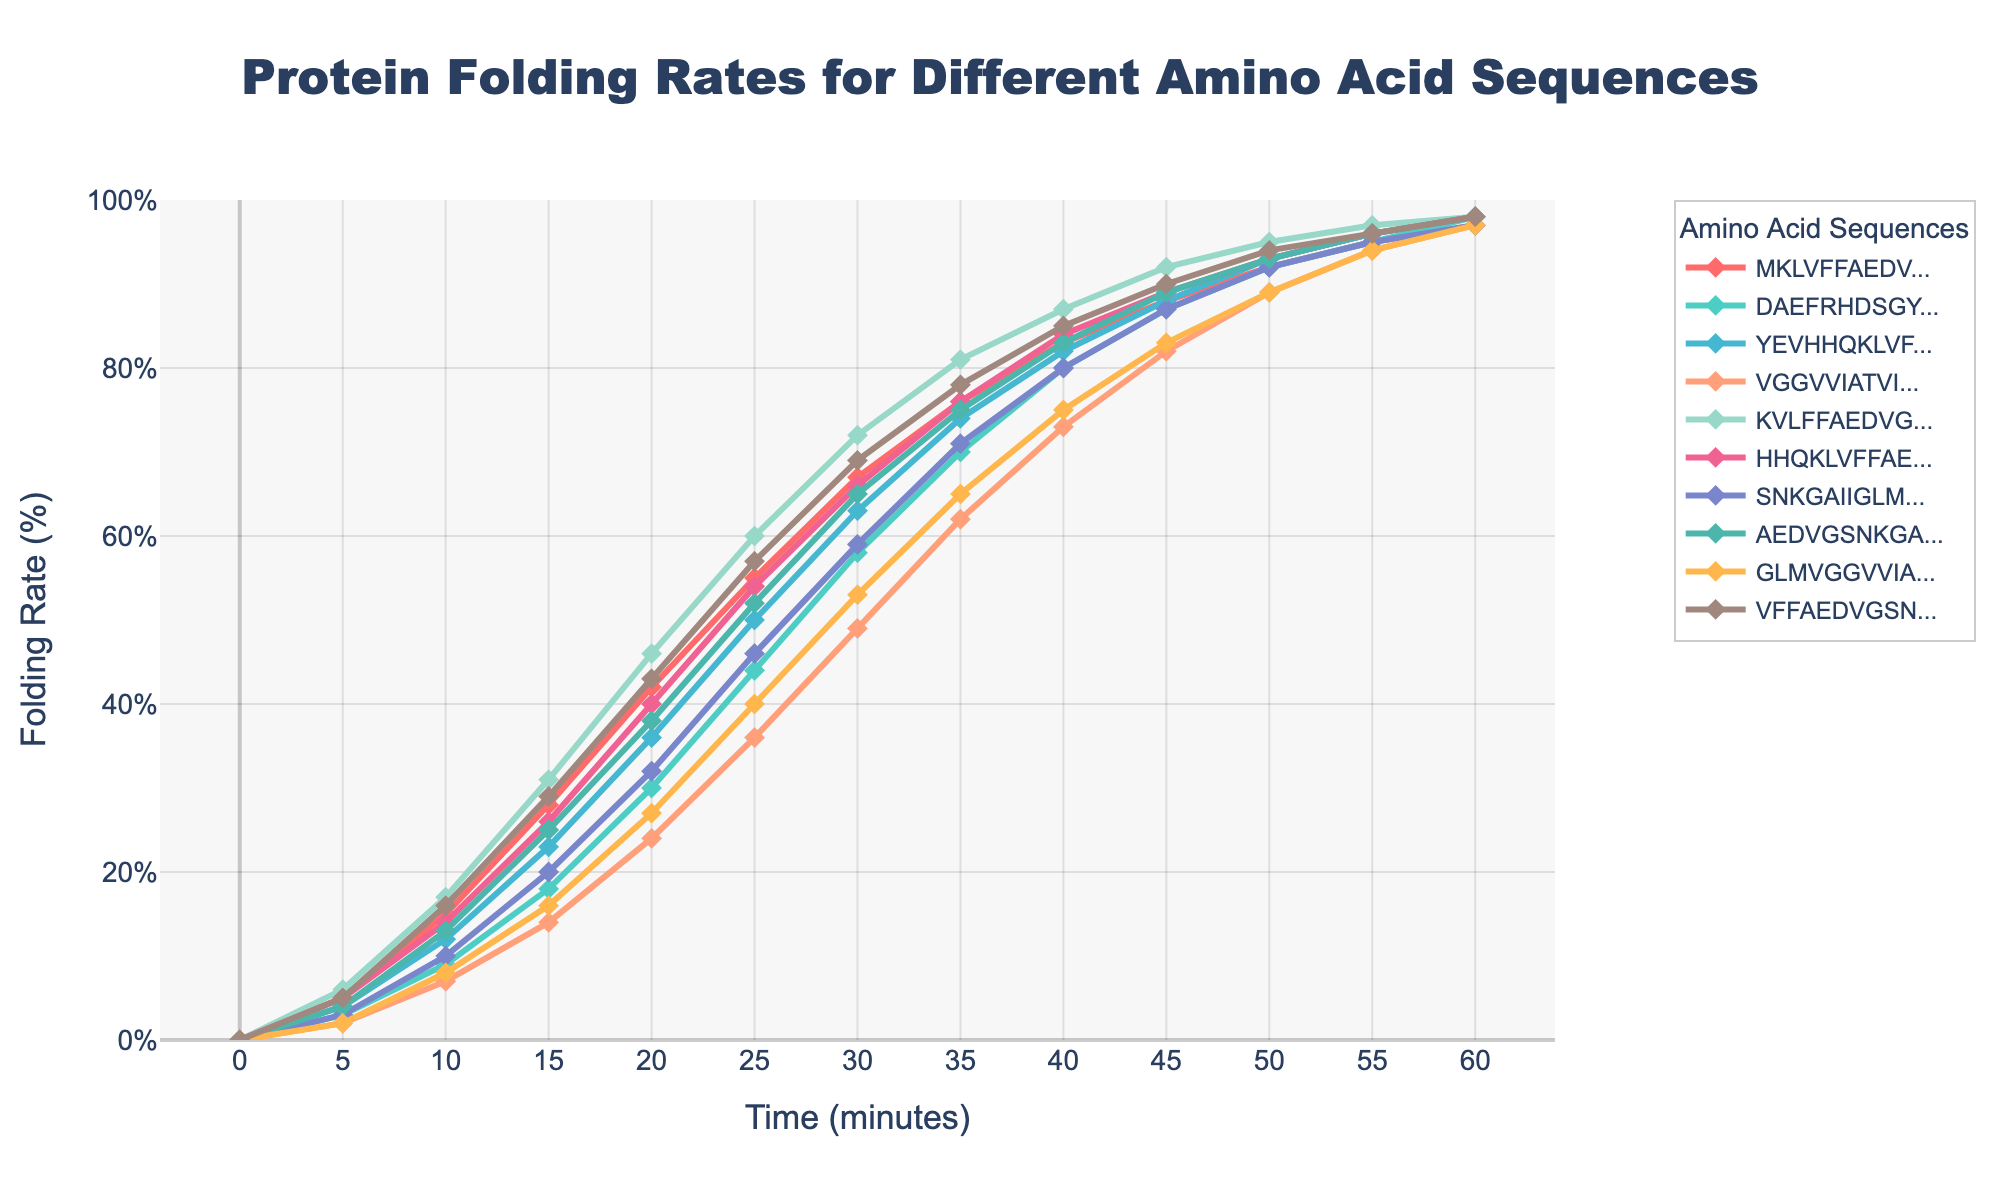Which amino acid sequence has the highest folding rate at 15 minutes? Look at the data points at the 15-minute mark for each sequence and find the highest value. The sequence "KVLFFAEDVGSNKGAIIGLMVGGVVIA" has a folding rate of 31%, which is the highest.
Answer: KVLFFAEDVGSNKGAIIGLMVGGVVIA Which sequence has a lower folding rate at 10 minutes, "YEVHHQKLVFFAEDVGSNKGAIIGLM" or "AEDVGSNKGAIIGLMVGGVVIATVIVI"? Compare the values for "YEVHHQKLVFFAEDVGSNKGAIIGLM" and "AEDVGSNKGAIIGLMVGGVVIATVIVI" at the 10-minute mark. The values are 12% and 13% respectively, making "YEVHHQKLVFFAEDVGSNKGAIIGLM" lower.
Answer: YEVHHQKLVFFAEDVGSNKGAIIGLM Which sequence shows the steepest increase in folding rate between 20 and 25 minutes? Find the difference between the values at 25 minutes and 20 minutes for each sequence. Compare these differences. The sequence "KVLFFAEDVGSNKGAIIGLMVGGVVIA" shows the steepest increase from 46% to 60%, which is 14%.
Answer: KVLFFAEDVGSNKGAIIGLMVGGVVIA What is the average folding rate at 30 minutes for all sequences? Sum the folding rates of all sequences at the 30-minute mark and divide by the number of sequences. The sum is 697 (67+58+63+49+72+66+59+65+53+69) and there are 10 sequences, so the average is 697/10 = 69.7%.
Answer: 69.7% Which sequence has the smallest final folding rate at 60 minutes? Look at the data points for each sequence at the 60-minute mark and find the smallest value. The sequence "MKLVFFAEDVGSNKGAIIGLMVGGVV" has the smallest final rate of 97%.
Answer: MKLVFFAEDVGSNKGAIIGLMVGGVV How does the folding rate of "VGGVVIATVIVITLVMLKKKQYTSIHHG" compare to "GLMVGGVVIATVIVITLVMLKKKQYTS" at 35 minutes? Compare the folding rates of both sequences at the 35-minute mark. The values are 62% for "VGGVVIATVIVITLVMLKKKQYTSIHHG" and 65% for "GLMVGGVVIATVIVITLVMLKKKQYTS". "GLMVGGVVIATVIVITLVMLKKKQYTS" is higher.
Answer: GLMVGGVVIATVIVITLVMLKKKQYTS What is the total increase in folding rate for "DAEFRHDSGYEVHHQKLVFFAEDVGS" from 0 to 20 minutes? Subtract the folding rate at 0 minutes from the folding rate at 20 minutes for "DAEFRHDSGYEVHHQKLVFFAEDVGS". The total increase is 30% - 0% = 30%.
Answer: 30% Which color represents the sequence "SNKGAIIGLMVGGVVIATVIVITLVML"? Identify the color associated with "SNKGAIIGLMVGGVVIATVIVITLVML" by its visual representation in the plot. The color is pinkish.
Answer: pinkish Which sequence achieved a folding rate of 90% first, and at what time? Look for the sequence that reaches 90% folding rate first and identify the corresponding time. The sequence "MKLVFFAEDVGSNKGAIIGLMVGGVV" achieves 90% at 45 minutes.
Answer: MKLVFFAEDVGSNKGAIIGLMVGGVV, 45 minutes 